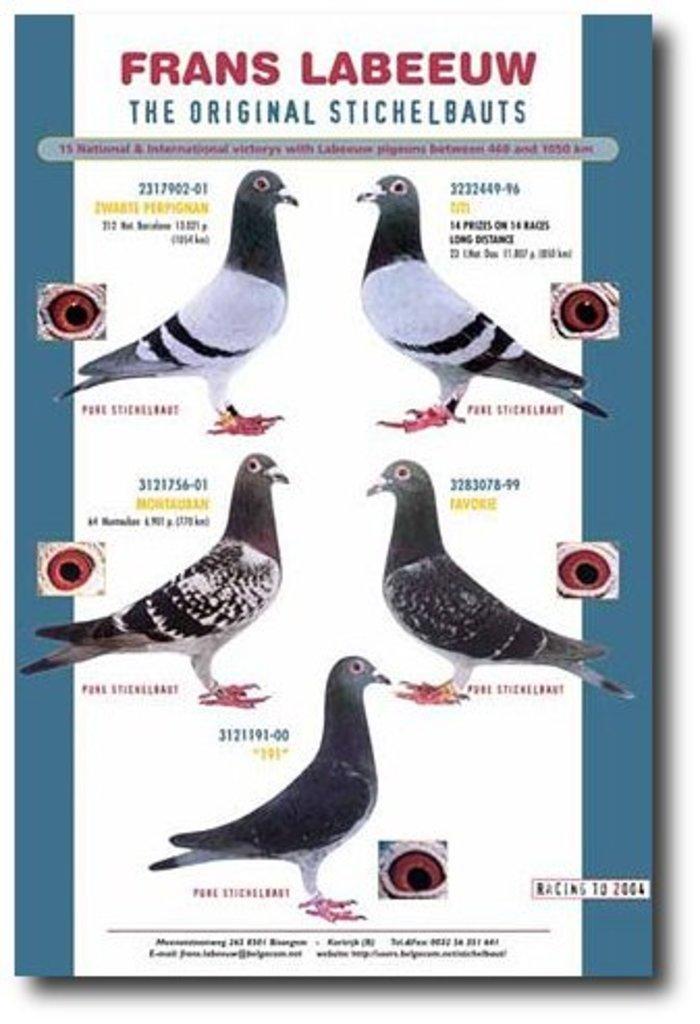How would you summarize this image in a sentence or two? This is a poster in this image we could see some birds, and some text. 